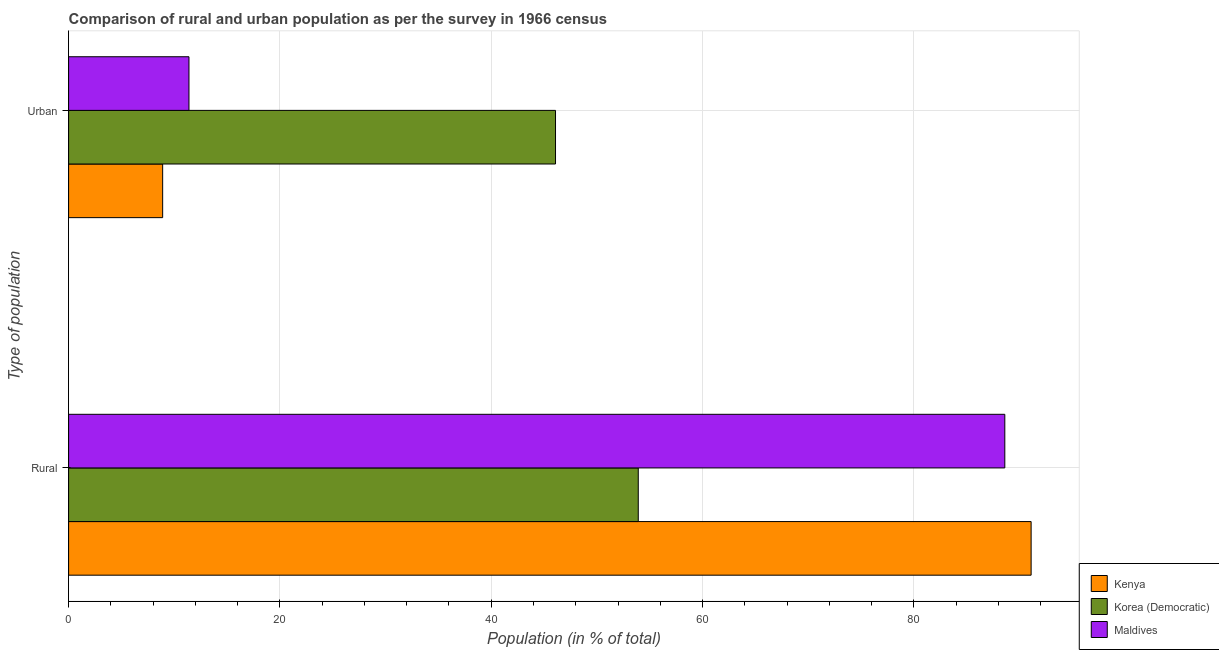How many groups of bars are there?
Keep it short and to the point. 2. Are the number of bars per tick equal to the number of legend labels?
Your answer should be very brief. Yes. How many bars are there on the 2nd tick from the top?
Ensure brevity in your answer.  3. How many bars are there on the 2nd tick from the bottom?
Offer a very short reply. 3. What is the label of the 1st group of bars from the top?
Your answer should be very brief. Urban. What is the rural population in Kenya?
Ensure brevity in your answer.  91.1. Across all countries, what is the maximum urban population?
Provide a succinct answer. 46.08. Across all countries, what is the minimum rural population?
Keep it short and to the point. 53.92. In which country was the urban population maximum?
Ensure brevity in your answer.  Korea (Democratic). In which country was the urban population minimum?
Give a very brief answer. Kenya. What is the total urban population in the graph?
Offer a terse response. 66.38. What is the difference between the urban population in Korea (Democratic) and that in Kenya?
Your answer should be very brief. 37.18. What is the difference between the rural population in Maldives and the urban population in Kenya?
Give a very brief answer. 79.71. What is the average urban population per country?
Your response must be concise. 22.13. What is the difference between the urban population and rural population in Korea (Democratic)?
Provide a succinct answer. -7.83. What is the ratio of the urban population in Maldives to that in Kenya?
Offer a very short reply. 1.28. Is the urban population in Korea (Democratic) less than that in Kenya?
Provide a short and direct response. No. What does the 1st bar from the top in Urban represents?
Give a very brief answer. Maldives. What does the 2nd bar from the bottom in Urban represents?
Provide a short and direct response. Korea (Democratic). How many bars are there?
Keep it short and to the point. 6. What is the difference between two consecutive major ticks on the X-axis?
Give a very brief answer. 20. Does the graph contain any zero values?
Your answer should be very brief. No. Does the graph contain grids?
Provide a succinct answer. Yes. Where does the legend appear in the graph?
Give a very brief answer. Bottom right. How many legend labels are there?
Make the answer very short. 3. What is the title of the graph?
Offer a very short reply. Comparison of rural and urban population as per the survey in 1966 census. Does "OECD members" appear as one of the legend labels in the graph?
Offer a very short reply. No. What is the label or title of the X-axis?
Ensure brevity in your answer.  Population (in % of total). What is the label or title of the Y-axis?
Offer a very short reply. Type of population. What is the Population (in % of total) of Kenya in Rural?
Provide a succinct answer. 91.1. What is the Population (in % of total) in Korea (Democratic) in Rural?
Make the answer very short. 53.92. What is the Population (in % of total) in Maldives in Rural?
Keep it short and to the point. 88.61. What is the Population (in % of total) in Kenya in Urban?
Offer a very short reply. 8.9. What is the Population (in % of total) in Korea (Democratic) in Urban?
Provide a succinct answer. 46.08. What is the Population (in % of total) of Maldives in Urban?
Provide a succinct answer. 11.39. Across all Type of population, what is the maximum Population (in % of total) of Kenya?
Your answer should be compact. 91.1. Across all Type of population, what is the maximum Population (in % of total) of Korea (Democratic)?
Provide a short and direct response. 53.92. Across all Type of population, what is the maximum Population (in % of total) of Maldives?
Your answer should be very brief. 88.61. Across all Type of population, what is the minimum Population (in % of total) of Kenya?
Your answer should be very brief. 8.9. Across all Type of population, what is the minimum Population (in % of total) of Korea (Democratic)?
Offer a very short reply. 46.08. Across all Type of population, what is the minimum Population (in % of total) of Maldives?
Your answer should be very brief. 11.39. What is the total Population (in % of total) of Kenya in the graph?
Ensure brevity in your answer.  100. What is the total Population (in % of total) in Korea (Democratic) in the graph?
Keep it short and to the point. 100. What is the difference between the Population (in % of total) of Kenya in Rural and that in Urban?
Make the answer very short. 82.2. What is the difference between the Population (in % of total) in Korea (Democratic) in Rural and that in Urban?
Ensure brevity in your answer.  7.83. What is the difference between the Population (in % of total) of Maldives in Rural and that in Urban?
Keep it short and to the point. 77.21. What is the difference between the Population (in % of total) in Kenya in Rural and the Population (in % of total) in Korea (Democratic) in Urban?
Keep it short and to the point. 45.01. What is the difference between the Population (in % of total) of Kenya in Rural and the Population (in % of total) of Maldives in Urban?
Give a very brief answer. 79.7. What is the difference between the Population (in % of total) of Korea (Democratic) in Rural and the Population (in % of total) of Maldives in Urban?
Provide a succinct answer. 42.52. What is the average Population (in % of total) of Korea (Democratic) per Type of population?
Your answer should be compact. 50. What is the difference between the Population (in % of total) in Kenya and Population (in % of total) in Korea (Democratic) in Rural?
Keep it short and to the point. 37.18. What is the difference between the Population (in % of total) in Kenya and Population (in % of total) in Maldives in Rural?
Ensure brevity in your answer.  2.49. What is the difference between the Population (in % of total) of Korea (Democratic) and Population (in % of total) of Maldives in Rural?
Ensure brevity in your answer.  -34.69. What is the difference between the Population (in % of total) of Kenya and Population (in % of total) of Korea (Democratic) in Urban?
Ensure brevity in your answer.  -37.18. What is the difference between the Population (in % of total) in Kenya and Population (in % of total) in Maldives in Urban?
Your answer should be compact. -2.49. What is the difference between the Population (in % of total) of Korea (Democratic) and Population (in % of total) of Maldives in Urban?
Your answer should be very brief. 34.69. What is the ratio of the Population (in % of total) of Kenya in Rural to that in Urban?
Offer a terse response. 10.23. What is the ratio of the Population (in % of total) of Korea (Democratic) in Rural to that in Urban?
Your answer should be compact. 1.17. What is the ratio of the Population (in % of total) in Maldives in Rural to that in Urban?
Your response must be concise. 7.78. What is the difference between the highest and the second highest Population (in % of total) of Kenya?
Your answer should be compact. 82.2. What is the difference between the highest and the second highest Population (in % of total) in Korea (Democratic)?
Your answer should be very brief. 7.83. What is the difference between the highest and the second highest Population (in % of total) in Maldives?
Provide a succinct answer. 77.21. What is the difference between the highest and the lowest Population (in % of total) of Kenya?
Your answer should be compact. 82.2. What is the difference between the highest and the lowest Population (in % of total) in Korea (Democratic)?
Offer a very short reply. 7.83. What is the difference between the highest and the lowest Population (in % of total) of Maldives?
Give a very brief answer. 77.21. 